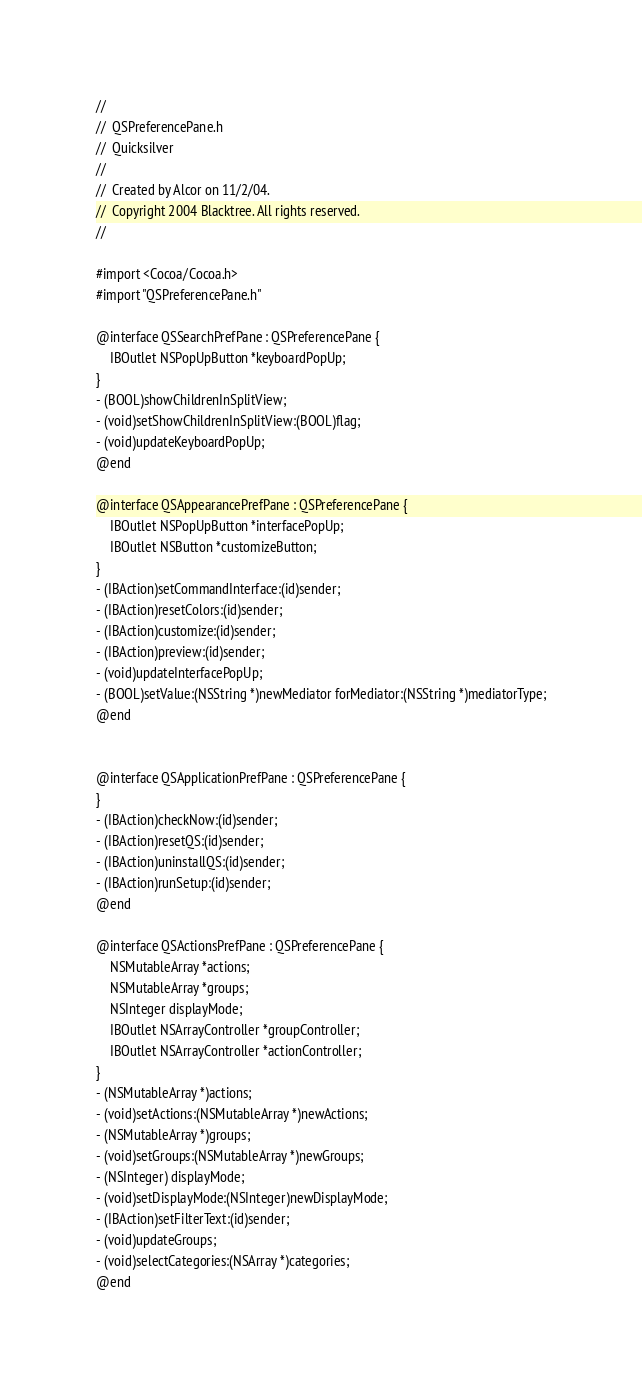Convert code to text. <code><loc_0><loc_0><loc_500><loc_500><_C_>//
//  QSPreferencePane.h
//  Quicksilver
//
//  Created by Alcor on 11/2/04.
//  Copyright 2004 Blacktree. All rights reserved.
//

#import <Cocoa/Cocoa.h>
#import "QSPreferencePane.h"

@interface QSSearchPrefPane : QSPreferencePane {
    IBOutlet NSPopUpButton *keyboardPopUp;
}
- (BOOL)showChildrenInSplitView;
- (void)setShowChildrenInSplitView:(BOOL)flag;
- (void)updateKeyboardPopUp;
@end

@interface QSAppearancePrefPane : QSPreferencePane {
	IBOutlet NSPopUpButton *interfacePopUp;
	IBOutlet NSButton *customizeButton;
}
- (IBAction)setCommandInterface:(id)sender;
- (IBAction)resetColors:(id)sender;
- (IBAction)customize:(id)sender;
- (IBAction)preview:(id)sender;
- (void)updateInterfacePopUp;
- (BOOL)setValue:(NSString *)newMediator forMediator:(NSString *)mediatorType;
@end


@interface QSApplicationPrefPane : QSPreferencePane {
}
- (IBAction)checkNow:(id)sender;
- (IBAction)resetQS:(id)sender;
- (IBAction)uninstallQS:(id)sender;
- (IBAction)runSetup:(id)sender;
@end

@interface QSActionsPrefPane : QSPreferencePane {
	NSMutableArray *actions;
	NSMutableArray *groups;
	NSInteger displayMode;
	IBOutlet NSArrayController *groupController;
	IBOutlet NSArrayController *actionController;
}
- (NSMutableArray *)actions;
- (void)setActions:(NSMutableArray *)newActions;
- (NSMutableArray *)groups;
- (void)setGroups:(NSMutableArray *)newGroups;
- (NSInteger) displayMode;
- (void)setDisplayMode:(NSInteger)newDisplayMode;
- (IBAction)setFilterText:(id)sender;
- (void)updateGroups;
- (void)selectCategories:(NSArray *)categories;
@end

</code> 